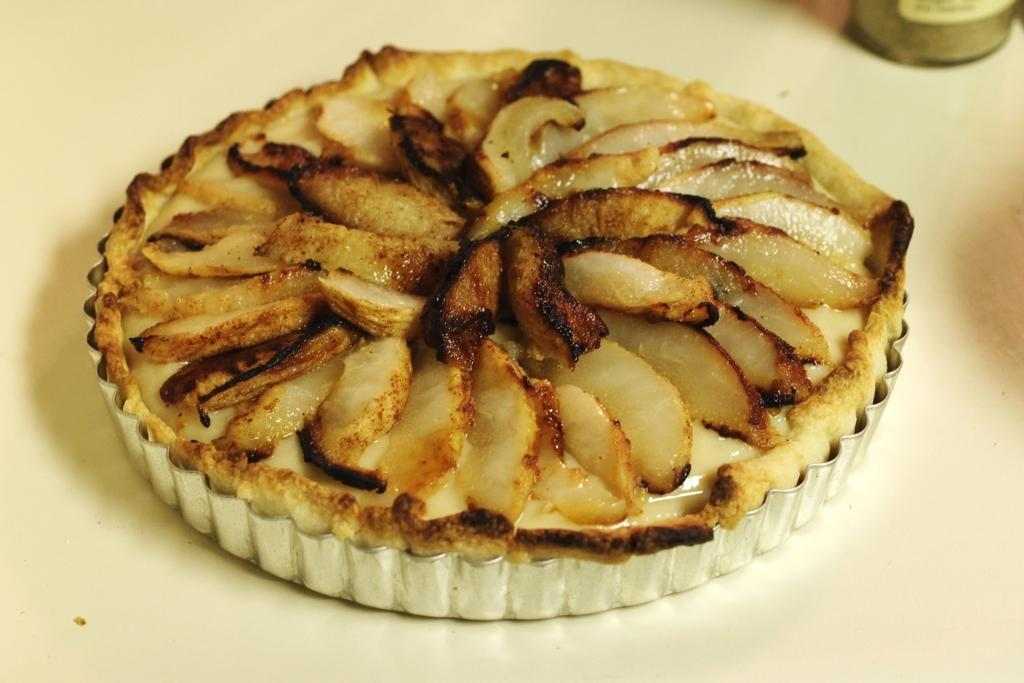What type of food is visible in the image? There is an apple pie in the image. On what surface is the apple pie placed? The apple pie is placed on a white table. What other object can be seen in the image besides the apple pie? There is a jar or bottle in the image. What type of sock is covering the apple pie in the image? There is no sock present in the image, and the apple pie is not covered by any type of sock. 